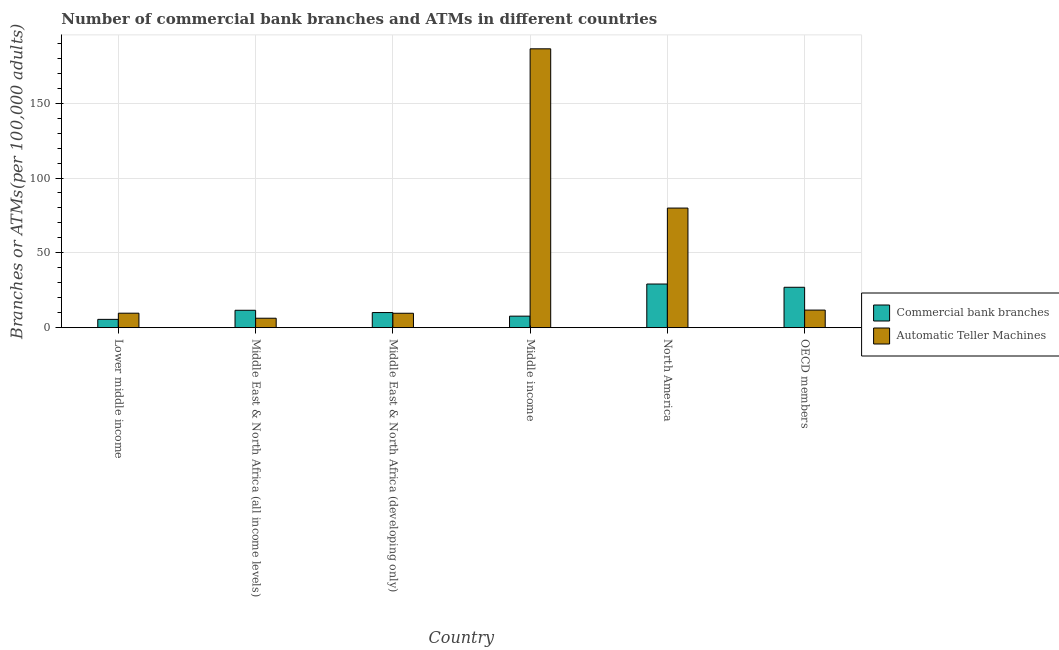How many different coloured bars are there?
Ensure brevity in your answer.  2. How many groups of bars are there?
Provide a succinct answer. 6. How many bars are there on the 2nd tick from the left?
Keep it short and to the point. 2. How many bars are there on the 4th tick from the right?
Provide a short and direct response. 2. What is the label of the 6th group of bars from the left?
Make the answer very short. OECD members. What is the number of atms in Middle East & North Africa (all income levels)?
Make the answer very short. 6.31. Across all countries, what is the maximum number of atms?
Give a very brief answer. 186.34. Across all countries, what is the minimum number of commercal bank branches?
Give a very brief answer. 5.54. In which country was the number of atms maximum?
Provide a short and direct response. Middle income. In which country was the number of commercal bank branches minimum?
Make the answer very short. Lower middle income. What is the total number of commercal bank branches in the graph?
Make the answer very short. 91.11. What is the difference between the number of atms in Middle East & North Africa (developing only) and that in OECD members?
Ensure brevity in your answer.  -2.12. What is the difference between the number of commercal bank branches in Middle income and the number of atms in Middle East & North Africa (all income levels)?
Ensure brevity in your answer.  1.39. What is the average number of commercal bank branches per country?
Keep it short and to the point. 15.19. What is the difference between the number of commercal bank branches and number of atms in Lower middle income?
Your response must be concise. -4.13. In how many countries, is the number of commercal bank branches greater than 90 ?
Your response must be concise. 0. What is the ratio of the number of atms in Middle East & North Africa (all income levels) to that in Middle income?
Your response must be concise. 0.03. Is the number of atms in Middle East & North Africa (developing only) less than that in OECD members?
Your answer should be very brief. Yes. Is the difference between the number of atms in Middle income and North America greater than the difference between the number of commercal bank branches in Middle income and North America?
Your answer should be very brief. Yes. What is the difference between the highest and the second highest number of atms?
Your response must be concise. 106.42. What is the difference between the highest and the lowest number of atms?
Provide a succinct answer. 180.03. In how many countries, is the number of atms greater than the average number of atms taken over all countries?
Make the answer very short. 2. What does the 1st bar from the left in North America represents?
Ensure brevity in your answer.  Commercial bank branches. What does the 2nd bar from the right in Middle East & North Africa (all income levels) represents?
Keep it short and to the point. Commercial bank branches. How many bars are there?
Make the answer very short. 12. How many countries are there in the graph?
Provide a succinct answer. 6. Where does the legend appear in the graph?
Provide a succinct answer. Center right. What is the title of the graph?
Your answer should be very brief. Number of commercial bank branches and ATMs in different countries. Does "Number of arrivals" appear as one of the legend labels in the graph?
Ensure brevity in your answer.  No. What is the label or title of the X-axis?
Provide a short and direct response. Country. What is the label or title of the Y-axis?
Make the answer very short. Branches or ATMs(per 100,0 adults). What is the Branches or ATMs(per 100,000 adults) of Commercial bank branches in Lower middle income?
Make the answer very short. 5.54. What is the Branches or ATMs(per 100,000 adults) of Automatic Teller Machines in Lower middle income?
Keep it short and to the point. 9.67. What is the Branches or ATMs(per 100,000 adults) of Commercial bank branches in Middle East & North Africa (all income levels)?
Your answer should be compact. 11.63. What is the Branches or ATMs(per 100,000 adults) in Automatic Teller Machines in Middle East & North Africa (all income levels)?
Offer a very short reply. 6.31. What is the Branches or ATMs(per 100,000 adults) of Commercial bank branches in Middle East & North Africa (developing only)?
Your answer should be very brief. 10.1. What is the Branches or ATMs(per 100,000 adults) of Automatic Teller Machines in Middle East & North Africa (developing only)?
Make the answer very short. 9.63. What is the Branches or ATMs(per 100,000 adults) of Commercial bank branches in Middle income?
Ensure brevity in your answer.  7.7. What is the Branches or ATMs(per 100,000 adults) in Automatic Teller Machines in Middle income?
Provide a short and direct response. 186.34. What is the Branches or ATMs(per 100,000 adults) in Commercial bank branches in North America?
Give a very brief answer. 29.16. What is the Branches or ATMs(per 100,000 adults) in Automatic Teller Machines in North America?
Give a very brief answer. 79.91. What is the Branches or ATMs(per 100,000 adults) of Commercial bank branches in OECD members?
Offer a very short reply. 26.99. What is the Branches or ATMs(per 100,000 adults) in Automatic Teller Machines in OECD members?
Give a very brief answer. 11.74. Across all countries, what is the maximum Branches or ATMs(per 100,000 adults) in Commercial bank branches?
Offer a very short reply. 29.16. Across all countries, what is the maximum Branches or ATMs(per 100,000 adults) in Automatic Teller Machines?
Your answer should be very brief. 186.34. Across all countries, what is the minimum Branches or ATMs(per 100,000 adults) of Commercial bank branches?
Your response must be concise. 5.54. Across all countries, what is the minimum Branches or ATMs(per 100,000 adults) of Automatic Teller Machines?
Make the answer very short. 6.31. What is the total Branches or ATMs(per 100,000 adults) of Commercial bank branches in the graph?
Provide a short and direct response. 91.11. What is the total Branches or ATMs(per 100,000 adults) of Automatic Teller Machines in the graph?
Provide a short and direct response. 303.59. What is the difference between the Branches or ATMs(per 100,000 adults) in Commercial bank branches in Lower middle income and that in Middle East & North Africa (all income levels)?
Provide a succinct answer. -6.09. What is the difference between the Branches or ATMs(per 100,000 adults) in Automatic Teller Machines in Lower middle income and that in Middle East & North Africa (all income levels)?
Provide a succinct answer. 3.36. What is the difference between the Branches or ATMs(per 100,000 adults) of Commercial bank branches in Lower middle income and that in Middle East & North Africa (developing only)?
Your response must be concise. -4.56. What is the difference between the Branches or ATMs(per 100,000 adults) in Automatic Teller Machines in Lower middle income and that in Middle East & North Africa (developing only)?
Make the answer very short. 0.04. What is the difference between the Branches or ATMs(per 100,000 adults) in Commercial bank branches in Lower middle income and that in Middle income?
Offer a terse response. -2.16. What is the difference between the Branches or ATMs(per 100,000 adults) of Automatic Teller Machines in Lower middle income and that in Middle income?
Make the answer very short. -176.67. What is the difference between the Branches or ATMs(per 100,000 adults) of Commercial bank branches in Lower middle income and that in North America?
Provide a short and direct response. -23.62. What is the difference between the Branches or ATMs(per 100,000 adults) in Automatic Teller Machines in Lower middle income and that in North America?
Keep it short and to the point. -70.25. What is the difference between the Branches or ATMs(per 100,000 adults) of Commercial bank branches in Lower middle income and that in OECD members?
Make the answer very short. -21.45. What is the difference between the Branches or ATMs(per 100,000 adults) of Automatic Teller Machines in Lower middle income and that in OECD members?
Make the answer very short. -2.08. What is the difference between the Branches or ATMs(per 100,000 adults) in Commercial bank branches in Middle East & North Africa (all income levels) and that in Middle East & North Africa (developing only)?
Give a very brief answer. 1.53. What is the difference between the Branches or ATMs(per 100,000 adults) in Automatic Teller Machines in Middle East & North Africa (all income levels) and that in Middle East & North Africa (developing only)?
Give a very brief answer. -3.32. What is the difference between the Branches or ATMs(per 100,000 adults) of Commercial bank branches in Middle East & North Africa (all income levels) and that in Middle income?
Provide a succinct answer. 3.93. What is the difference between the Branches or ATMs(per 100,000 adults) in Automatic Teller Machines in Middle East & North Africa (all income levels) and that in Middle income?
Keep it short and to the point. -180.03. What is the difference between the Branches or ATMs(per 100,000 adults) of Commercial bank branches in Middle East & North Africa (all income levels) and that in North America?
Ensure brevity in your answer.  -17.54. What is the difference between the Branches or ATMs(per 100,000 adults) in Automatic Teller Machines in Middle East & North Africa (all income levels) and that in North America?
Your response must be concise. -73.6. What is the difference between the Branches or ATMs(per 100,000 adults) of Commercial bank branches in Middle East & North Africa (all income levels) and that in OECD members?
Give a very brief answer. -15.36. What is the difference between the Branches or ATMs(per 100,000 adults) in Automatic Teller Machines in Middle East & North Africa (all income levels) and that in OECD members?
Your answer should be very brief. -5.43. What is the difference between the Branches or ATMs(per 100,000 adults) of Commercial bank branches in Middle East & North Africa (developing only) and that in Middle income?
Offer a terse response. 2.4. What is the difference between the Branches or ATMs(per 100,000 adults) in Automatic Teller Machines in Middle East & North Africa (developing only) and that in Middle income?
Provide a succinct answer. -176.71. What is the difference between the Branches or ATMs(per 100,000 adults) of Commercial bank branches in Middle East & North Africa (developing only) and that in North America?
Your response must be concise. -19.06. What is the difference between the Branches or ATMs(per 100,000 adults) in Automatic Teller Machines in Middle East & North Africa (developing only) and that in North America?
Your answer should be very brief. -70.29. What is the difference between the Branches or ATMs(per 100,000 adults) of Commercial bank branches in Middle East & North Africa (developing only) and that in OECD members?
Your answer should be compact. -16.89. What is the difference between the Branches or ATMs(per 100,000 adults) in Automatic Teller Machines in Middle East & North Africa (developing only) and that in OECD members?
Make the answer very short. -2.12. What is the difference between the Branches or ATMs(per 100,000 adults) in Commercial bank branches in Middle income and that in North America?
Your answer should be compact. -21.46. What is the difference between the Branches or ATMs(per 100,000 adults) of Automatic Teller Machines in Middle income and that in North America?
Your response must be concise. 106.42. What is the difference between the Branches or ATMs(per 100,000 adults) of Commercial bank branches in Middle income and that in OECD members?
Your response must be concise. -19.29. What is the difference between the Branches or ATMs(per 100,000 adults) of Automatic Teller Machines in Middle income and that in OECD members?
Your answer should be compact. 174.59. What is the difference between the Branches or ATMs(per 100,000 adults) of Commercial bank branches in North America and that in OECD members?
Offer a very short reply. 2.18. What is the difference between the Branches or ATMs(per 100,000 adults) in Automatic Teller Machines in North America and that in OECD members?
Provide a short and direct response. 68.17. What is the difference between the Branches or ATMs(per 100,000 adults) of Commercial bank branches in Lower middle income and the Branches or ATMs(per 100,000 adults) of Automatic Teller Machines in Middle East & North Africa (all income levels)?
Provide a short and direct response. -0.77. What is the difference between the Branches or ATMs(per 100,000 adults) of Commercial bank branches in Lower middle income and the Branches or ATMs(per 100,000 adults) of Automatic Teller Machines in Middle East & North Africa (developing only)?
Your response must be concise. -4.09. What is the difference between the Branches or ATMs(per 100,000 adults) of Commercial bank branches in Lower middle income and the Branches or ATMs(per 100,000 adults) of Automatic Teller Machines in Middle income?
Your answer should be compact. -180.8. What is the difference between the Branches or ATMs(per 100,000 adults) in Commercial bank branches in Lower middle income and the Branches or ATMs(per 100,000 adults) in Automatic Teller Machines in North America?
Provide a short and direct response. -74.37. What is the difference between the Branches or ATMs(per 100,000 adults) of Commercial bank branches in Lower middle income and the Branches or ATMs(per 100,000 adults) of Automatic Teller Machines in OECD members?
Provide a short and direct response. -6.2. What is the difference between the Branches or ATMs(per 100,000 adults) in Commercial bank branches in Middle East & North Africa (all income levels) and the Branches or ATMs(per 100,000 adults) in Automatic Teller Machines in Middle East & North Africa (developing only)?
Provide a succinct answer. 2. What is the difference between the Branches or ATMs(per 100,000 adults) of Commercial bank branches in Middle East & North Africa (all income levels) and the Branches or ATMs(per 100,000 adults) of Automatic Teller Machines in Middle income?
Provide a succinct answer. -174.71. What is the difference between the Branches or ATMs(per 100,000 adults) in Commercial bank branches in Middle East & North Africa (all income levels) and the Branches or ATMs(per 100,000 adults) in Automatic Teller Machines in North America?
Make the answer very short. -68.29. What is the difference between the Branches or ATMs(per 100,000 adults) in Commercial bank branches in Middle East & North Africa (all income levels) and the Branches or ATMs(per 100,000 adults) in Automatic Teller Machines in OECD members?
Offer a terse response. -0.12. What is the difference between the Branches or ATMs(per 100,000 adults) of Commercial bank branches in Middle East & North Africa (developing only) and the Branches or ATMs(per 100,000 adults) of Automatic Teller Machines in Middle income?
Make the answer very short. -176.24. What is the difference between the Branches or ATMs(per 100,000 adults) of Commercial bank branches in Middle East & North Africa (developing only) and the Branches or ATMs(per 100,000 adults) of Automatic Teller Machines in North America?
Offer a very short reply. -69.81. What is the difference between the Branches or ATMs(per 100,000 adults) of Commercial bank branches in Middle East & North Africa (developing only) and the Branches or ATMs(per 100,000 adults) of Automatic Teller Machines in OECD members?
Give a very brief answer. -1.64. What is the difference between the Branches or ATMs(per 100,000 adults) of Commercial bank branches in Middle income and the Branches or ATMs(per 100,000 adults) of Automatic Teller Machines in North America?
Provide a short and direct response. -72.21. What is the difference between the Branches or ATMs(per 100,000 adults) of Commercial bank branches in Middle income and the Branches or ATMs(per 100,000 adults) of Automatic Teller Machines in OECD members?
Provide a succinct answer. -4.04. What is the difference between the Branches or ATMs(per 100,000 adults) in Commercial bank branches in North America and the Branches or ATMs(per 100,000 adults) in Automatic Teller Machines in OECD members?
Give a very brief answer. 17.42. What is the average Branches or ATMs(per 100,000 adults) in Commercial bank branches per country?
Provide a short and direct response. 15.19. What is the average Branches or ATMs(per 100,000 adults) of Automatic Teller Machines per country?
Provide a short and direct response. 50.6. What is the difference between the Branches or ATMs(per 100,000 adults) in Commercial bank branches and Branches or ATMs(per 100,000 adults) in Automatic Teller Machines in Lower middle income?
Give a very brief answer. -4.13. What is the difference between the Branches or ATMs(per 100,000 adults) in Commercial bank branches and Branches or ATMs(per 100,000 adults) in Automatic Teller Machines in Middle East & North Africa (all income levels)?
Provide a short and direct response. 5.32. What is the difference between the Branches or ATMs(per 100,000 adults) in Commercial bank branches and Branches or ATMs(per 100,000 adults) in Automatic Teller Machines in Middle East & North Africa (developing only)?
Ensure brevity in your answer.  0.47. What is the difference between the Branches or ATMs(per 100,000 adults) of Commercial bank branches and Branches or ATMs(per 100,000 adults) of Automatic Teller Machines in Middle income?
Keep it short and to the point. -178.64. What is the difference between the Branches or ATMs(per 100,000 adults) of Commercial bank branches and Branches or ATMs(per 100,000 adults) of Automatic Teller Machines in North America?
Provide a short and direct response. -50.75. What is the difference between the Branches or ATMs(per 100,000 adults) in Commercial bank branches and Branches or ATMs(per 100,000 adults) in Automatic Teller Machines in OECD members?
Provide a short and direct response. 15.24. What is the ratio of the Branches or ATMs(per 100,000 adults) of Commercial bank branches in Lower middle income to that in Middle East & North Africa (all income levels)?
Offer a very short reply. 0.48. What is the ratio of the Branches or ATMs(per 100,000 adults) in Automatic Teller Machines in Lower middle income to that in Middle East & North Africa (all income levels)?
Offer a very short reply. 1.53. What is the ratio of the Branches or ATMs(per 100,000 adults) of Commercial bank branches in Lower middle income to that in Middle East & North Africa (developing only)?
Your answer should be very brief. 0.55. What is the ratio of the Branches or ATMs(per 100,000 adults) in Automatic Teller Machines in Lower middle income to that in Middle East & North Africa (developing only)?
Ensure brevity in your answer.  1. What is the ratio of the Branches or ATMs(per 100,000 adults) in Commercial bank branches in Lower middle income to that in Middle income?
Make the answer very short. 0.72. What is the ratio of the Branches or ATMs(per 100,000 adults) in Automatic Teller Machines in Lower middle income to that in Middle income?
Your answer should be compact. 0.05. What is the ratio of the Branches or ATMs(per 100,000 adults) of Commercial bank branches in Lower middle income to that in North America?
Provide a short and direct response. 0.19. What is the ratio of the Branches or ATMs(per 100,000 adults) of Automatic Teller Machines in Lower middle income to that in North America?
Provide a succinct answer. 0.12. What is the ratio of the Branches or ATMs(per 100,000 adults) in Commercial bank branches in Lower middle income to that in OECD members?
Your answer should be very brief. 0.21. What is the ratio of the Branches or ATMs(per 100,000 adults) in Automatic Teller Machines in Lower middle income to that in OECD members?
Provide a succinct answer. 0.82. What is the ratio of the Branches or ATMs(per 100,000 adults) of Commercial bank branches in Middle East & North Africa (all income levels) to that in Middle East & North Africa (developing only)?
Your answer should be very brief. 1.15. What is the ratio of the Branches or ATMs(per 100,000 adults) of Automatic Teller Machines in Middle East & North Africa (all income levels) to that in Middle East & North Africa (developing only)?
Your answer should be very brief. 0.66. What is the ratio of the Branches or ATMs(per 100,000 adults) in Commercial bank branches in Middle East & North Africa (all income levels) to that in Middle income?
Keep it short and to the point. 1.51. What is the ratio of the Branches or ATMs(per 100,000 adults) in Automatic Teller Machines in Middle East & North Africa (all income levels) to that in Middle income?
Your answer should be compact. 0.03. What is the ratio of the Branches or ATMs(per 100,000 adults) in Commercial bank branches in Middle East & North Africa (all income levels) to that in North America?
Your answer should be compact. 0.4. What is the ratio of the Branches or ATMs(per 100,000 adults) in Automatic Teller Machines in Middle East & North Africa (all income levels) to that in North America?
Offer a very short reply. 0.08. What is the ratio of the Branches or ATMs(per 100,000 adults) in Commercial bank branches in Middle East & North Africa (all income levels) to that in OECD members?
Your answer should be very brief. 0.43. What is the ratio of the Branches or ATMs(per 100,000 adults) of Automatic Teller Machines in Middle East & North Africa (all income levels) to that in OECD members?
Offer a very short reply. 0.54. What is the ratio of the Branches or ATMs(per 100,000 adults) of Commercial bank branches in Middle East & North Africa (developing only) to that in Middle income?
Make the answer very short. 1.31. What is the ratio of the Branches or ATMs(per 100,000 adults) of Automatic Teller Machines in Middle East & North Africa (developing only) to that in Middle income?
Your response must be concise. 0.05. What is the ratio of the Branches or ATMs(per 100,000 adults) of Commercial bank branches in Middle East & North Africa (developing only) to that in North America?
Your answer should be very brief. 0.35. What is the ratio of the Branches or ATMs(per 100,000 adults) of Automatic Teller Machines in Middle East & North Africa (developing only) to that in North America?
Your response must be concise. 0.12. What is the ratio of the Branches or ATMs(per 100,000 adults) in Commercial bank branches in Middle East & North Africa (developing only) to that in OECD members?
Provide a succinct answer. 0.37. What is the ratio of the Branches or ATMs(per 100,000 adults) in Automatic Teller Machines in Middle East & North Africa (developing only) to that in OECD members?
Provide a short and direct response. 0.82. What is the ratio of the Branches or ATMs(per 100,000 adults) in Commercial bank branches in Middle income to that in North America?
Keep it short and to the point. 0.26. What is the ratio of the Branches or ATMs(per 100,000 adults) of Automatic Teller Machines in Middle income to that in North America?
Offer a terse response. 2.33. What is the ratio of the Branches or ATMs(per 100,000 adults) of Commercial bank branches in Middle income to that in OECD members?
Your answer should be compact. 0.29. What is the ratio of the Branches or ATMs(per 100,000 adults) of Automatic Teller Machines in Middle income to that in OECD members?
Provide a short and direct response. 15.87. What is the ratio of the Branches or ATMs(per 100,000 adults) of Commercial bank branches in North America to that in OECD members?
Provide a succinct answer. 1.08. What is the ratio of the Branches or ATMs(per 100,000 adults) of Automatic Teller Machines in North America to that in OECD members?
Provide a succinct answer. 6.81. What is the difference between the highest and the second highest Branches or ATMs(per 100,000 adults) in Commercial bank branches?
Offer a very short reply. 2.18. What is the difference between the highest and the second highest Branches or ATMs(per 100,000 adults) in Automatic Teller Machines?
Provide a succinct answer. 106.42. What is the difference between the highest and the lowest Branches or ATMs(per 100,000 adults) in Commercial bank branches?
Your answer should be compact. 23.62. What is the difference between the highest and the lowest Branches or ATMs(per 100,000 adults) of Automatic Teller Machines?
Your response must be concise. 180.03. 